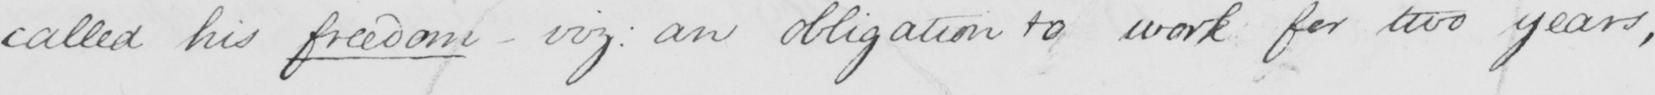Please transcribe the handwritten text in this image. called his freedom  _  viz :  an obligation to work for two years , 